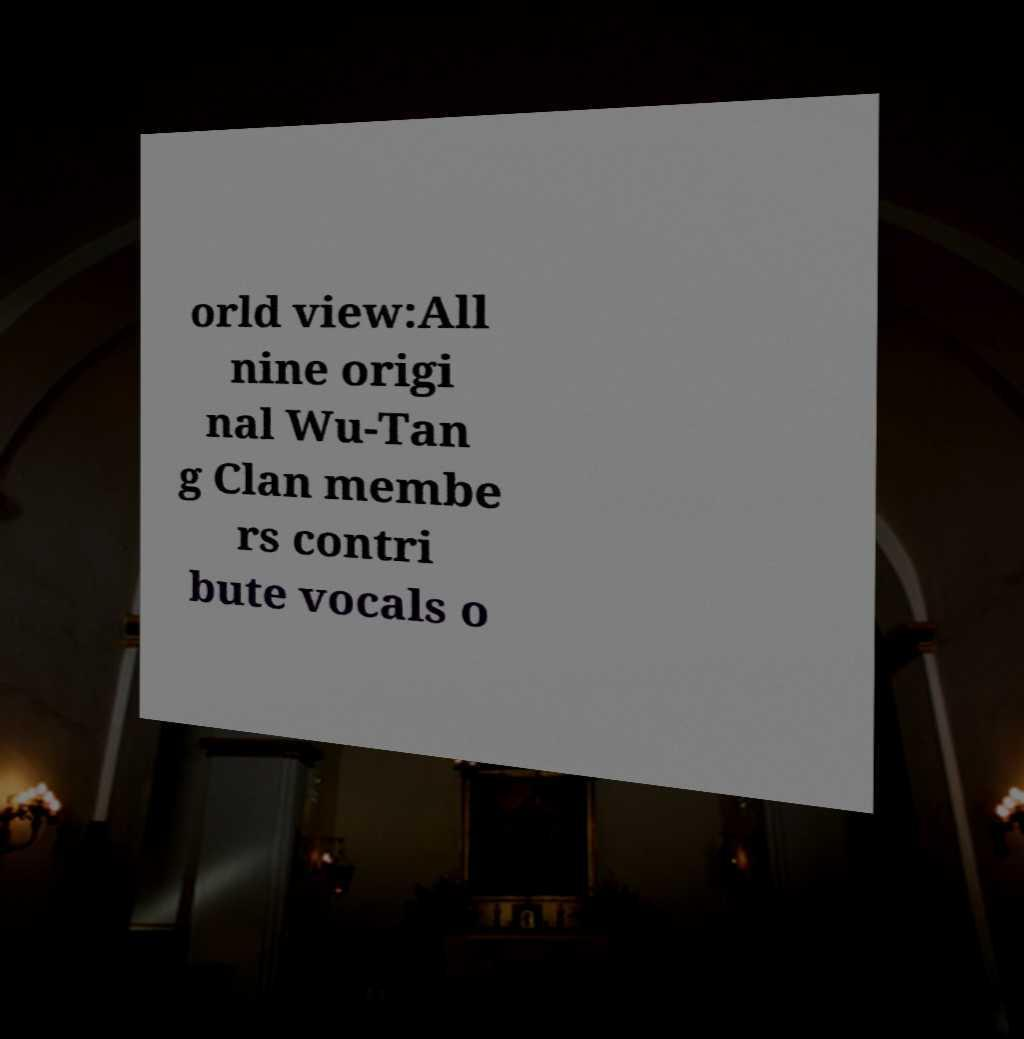Could you extract and type out the text from this image? orld view:All nine origi nal Wu-Tan g Clan membe rs contri bute vocals o 